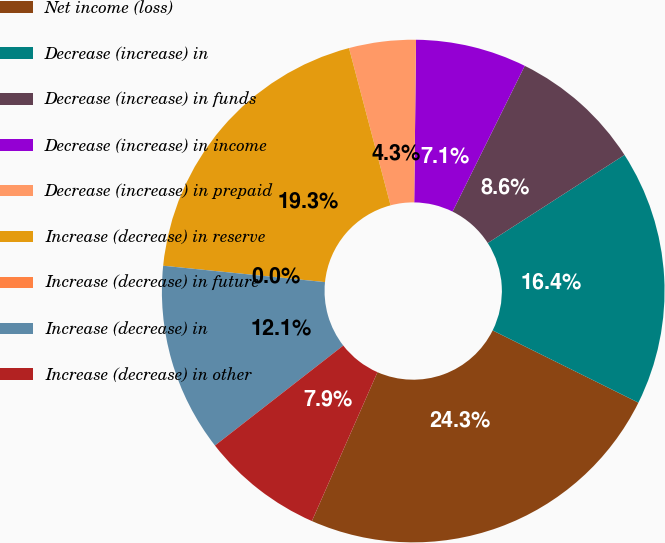<chart> <loc_0><loc_0><loc_500><loc_500><pie_chart><fcel>Net income (loss)<fcel>Decrease (increase) in<fcel>Decrease (increase) in funds<fcel>Decrease (increase) in income<fcel>Decrease (increase) in prepaid<fcel>Increase (decrease) in reserve<fcel>Increase (decrease) in future<fcel>Increase (decrease) in<fcel>Increase (decrease) in other<nl><fcel>24.28%<fcel>16.43%<fcel>8.57%<fcel>7.14%<fcel>4.29%<fcel>19.28%<fcel>0.0%<fcel>12.14%<fcel>7.86%<nl></chart> 